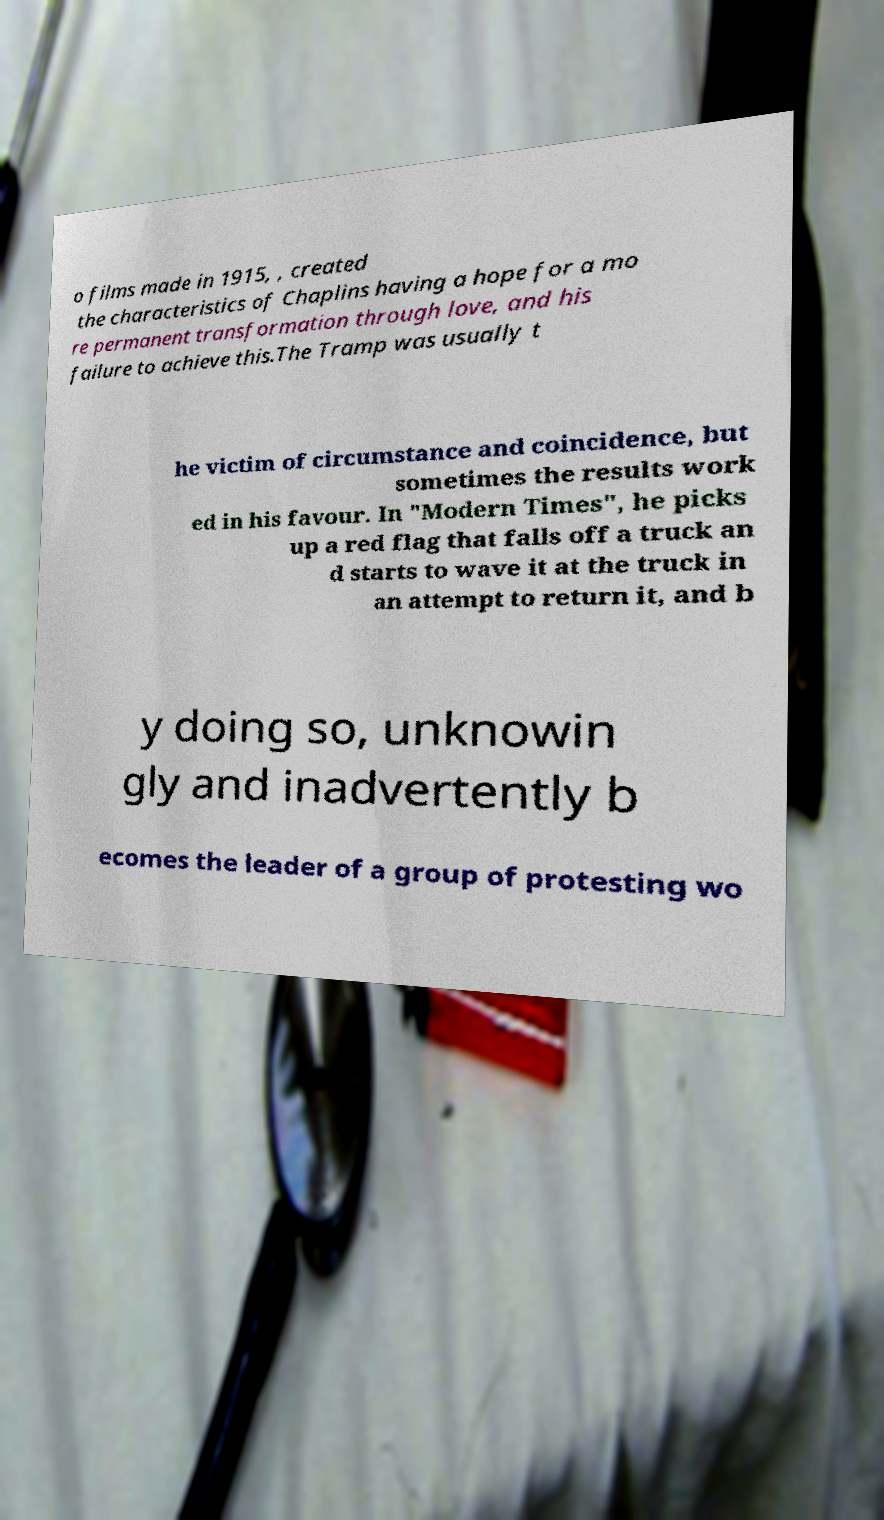Can you accurately transcribe the text from the provided image for me? o films made in 1915, , created the characteristics of Chaplins having a hope for a mo re permanent transformation through love, and his failure to achieve this.The Tramp was usually t he victim of circumstance and coincidence, but sometimes the results work ed in his favour. In "Modern Times", he picks up a red flag that falls off a truck an d starts to wave it at the truck in an attempt to return it, and b y doing so, unknowin gly and inadvertently b ecomes the leader of a group of protesting wo 